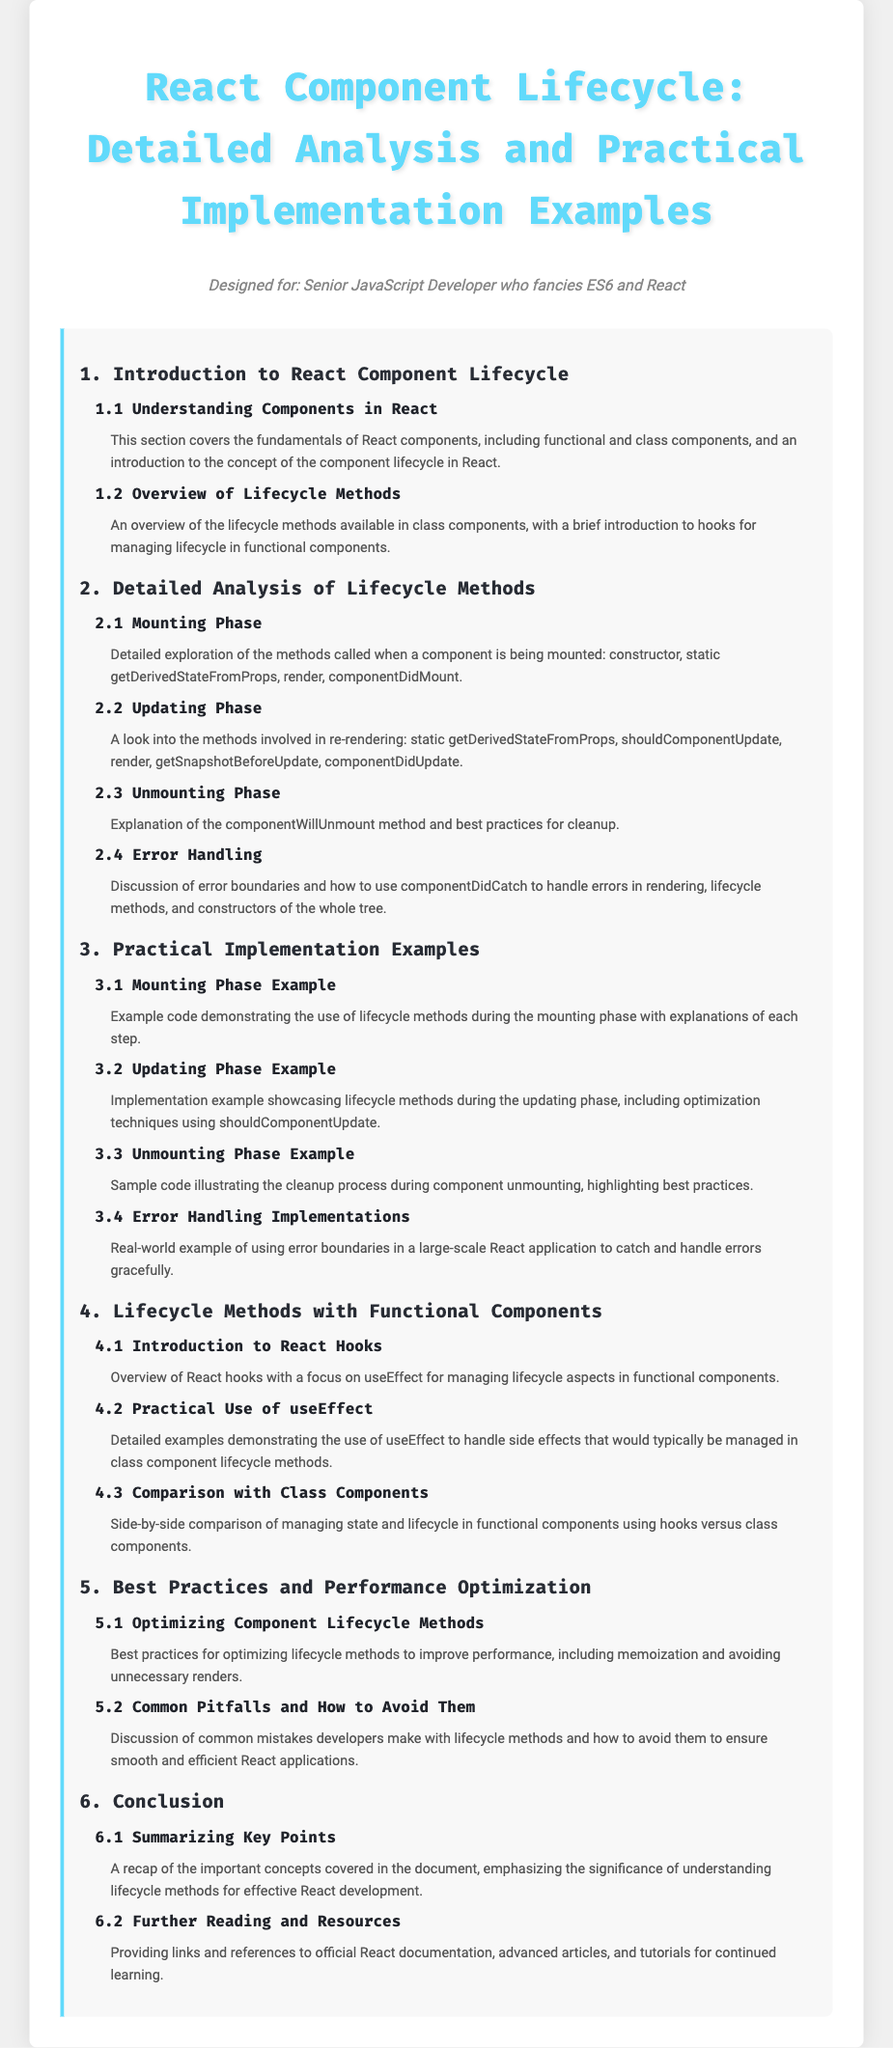What is the first section of the document? The first section is titled "Introduction to React Component Lifecycle," which introduces the topic of component lifecycle.
Answer: Introduction to React Component Lifecycle How many phases are there in the React component lifecycle? The document outlines three main phases in the lifecycle of a React component: Mounting, Updating, and Unmounting.
Answer: Three What method is explained in the unmounting phase? The document explains the "componentWillUnmount" method in the unmounting phase.
Answer: componentWillUnmount What is used to manage lifecycle aspects in functional components? The document discusses the usage of "useEffect" for managing lifecycle aspects in functional components.
Answer: useEffect Which section covers best practices for performance optimization? The section titled "Best Practices and Performance Optimization" addresses this topic.
Answer: Best Practices and Performance Optimization What do error boundaries do as discussed in the document? The document mentions that error boundaries are used to catch and handle errors during rendering and lifecycle methods in components.
Answer: Catch and handle errors Which hook is emphasized for managing side effects? The section titled "Practical Use of useEffect" highlights the use of the "useEffect" hook for managing side effects.
Answer: useEffect What is the last section of the document? The last section is titled "Conclusion" which summarizes key points covered in the document.
Answer: Conclusion 